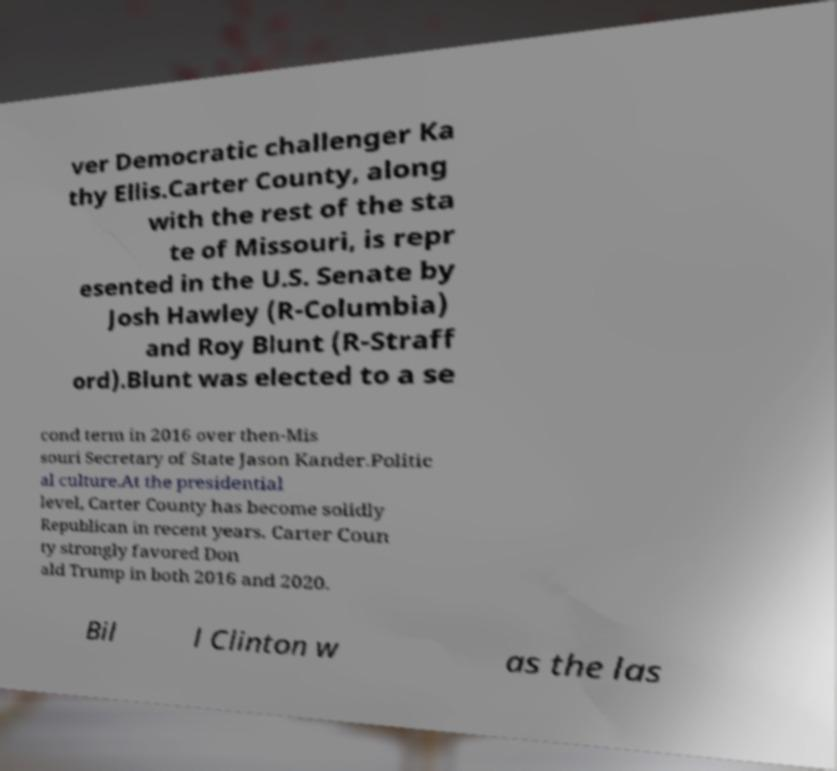What messages or text are displayed in this image? I need them in a readable, typed format. ver Democratic challenger Ka thy Ellis.Carter County, along with the rest of the sta te of Missouri, is repr esented in the U.S. Senate by Josh Hawley (R-Columbia) and Roy Blunt (R-Straff ord).Blunt was elected to a se cond term in 2016 over then-Mis souri Secretary of State Jason Kander.Politic al culture.At the presidential level, Carter County has become solidly Republican in recent years. Carter Coun ty strongly favored Don ald Trump in both 2016 and 2020. Bil l Clinton w as the las 